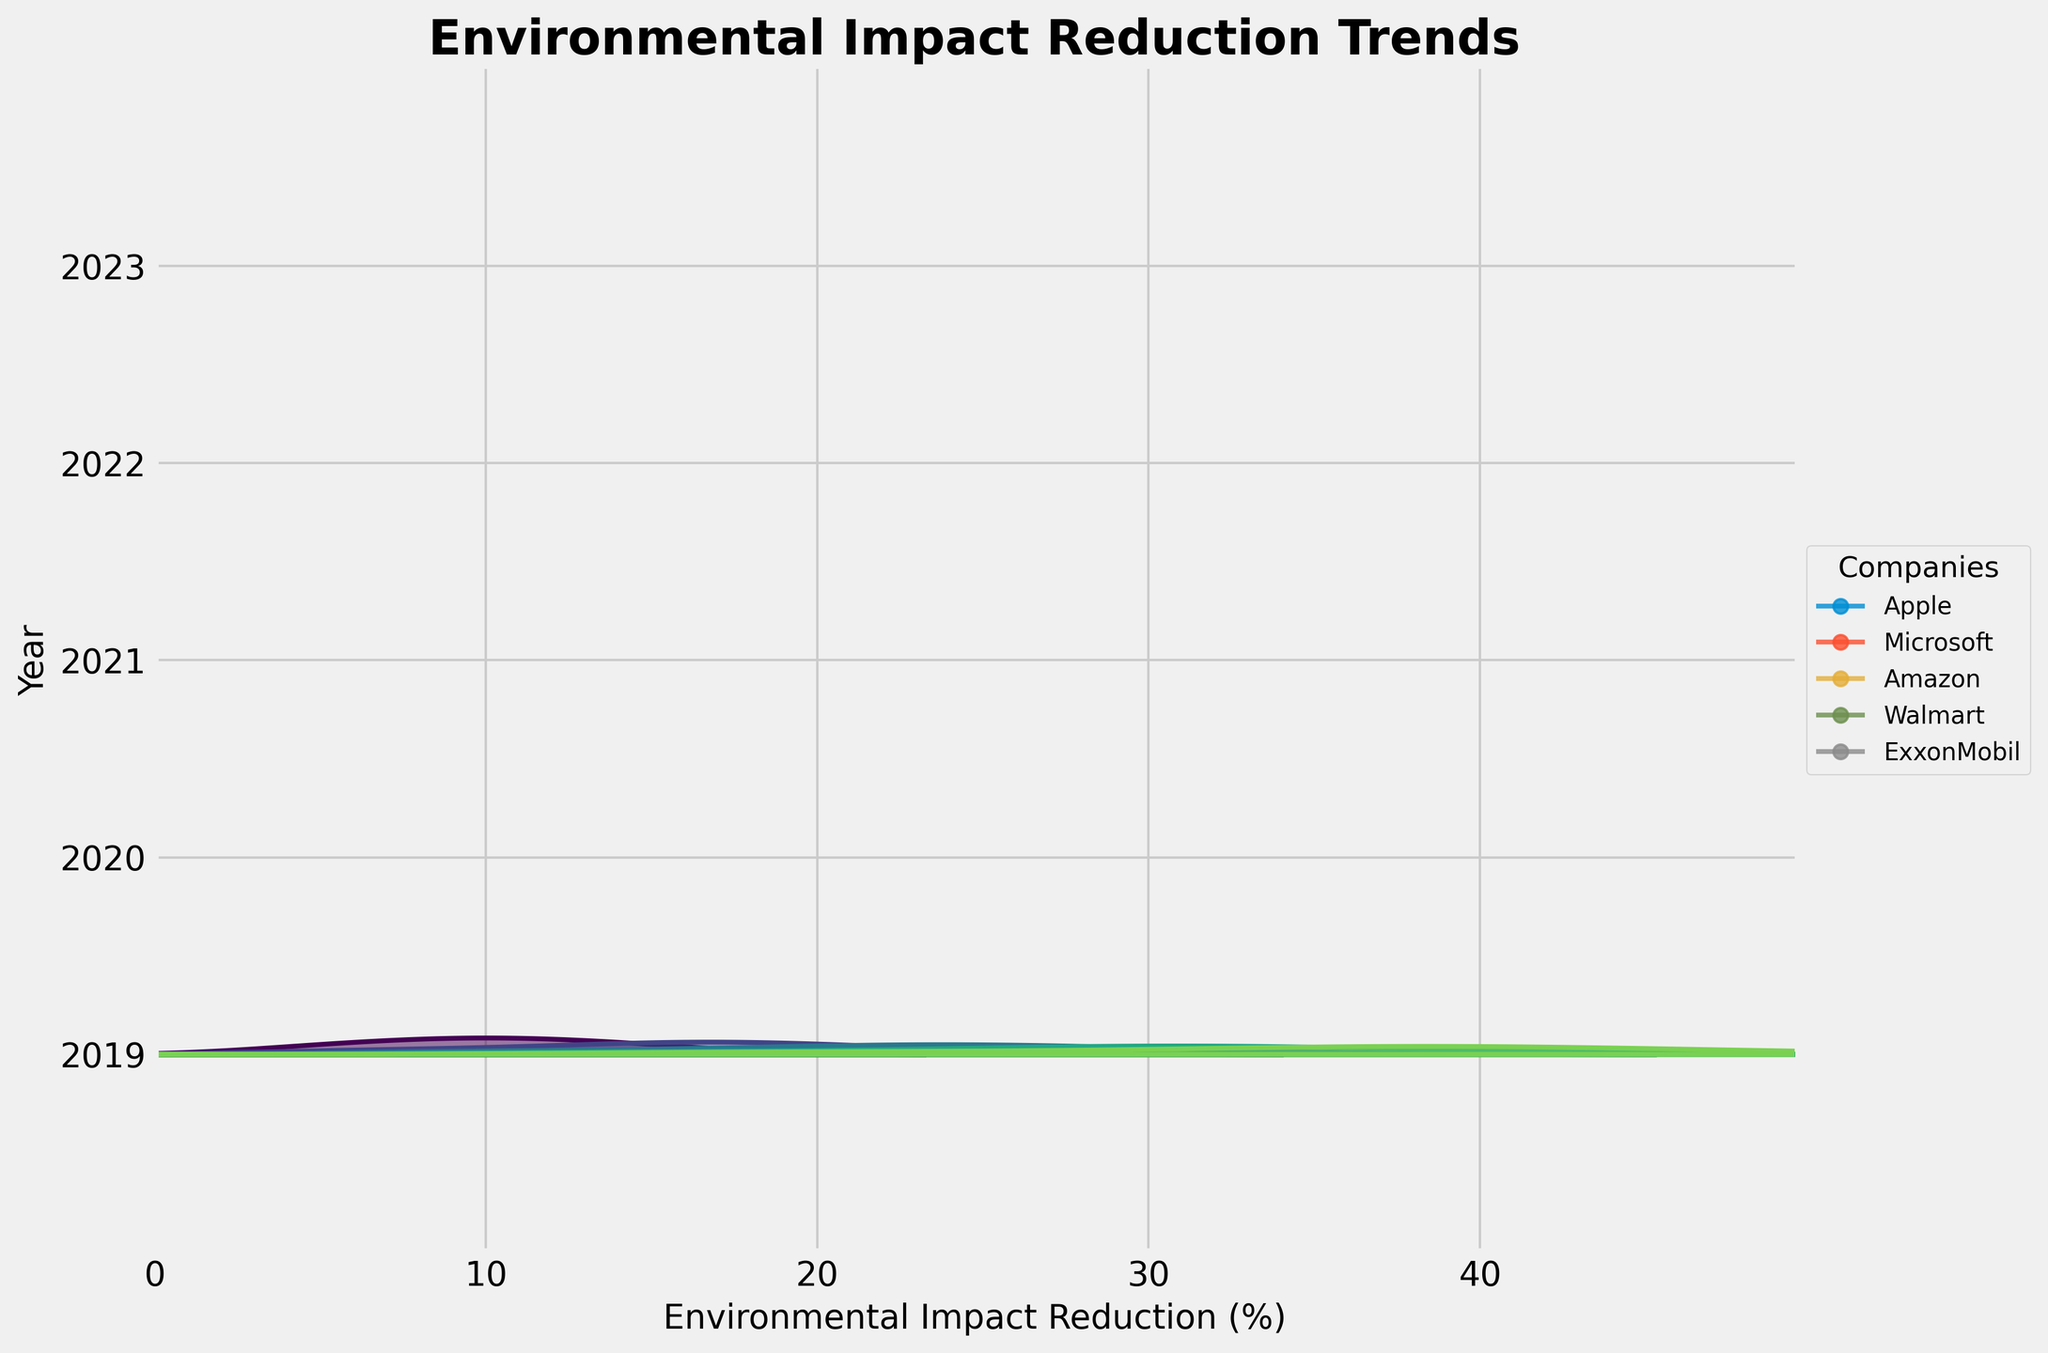How many years are displayed in the figure? The y-axis is labeled "Year," and it has five tick marks shown for 2019, 2020, 2021, 2022, and 2023.
Answer: 5 Which company has the highest environmental impact reduction in 2023? Looking at the plotted lines in the figure, Microsoft has the highest point on the environmental impact reduction axis in 2023.
Answer: Microsoft What is the color gradient representing in the plot? The shading in the plot transitions through different colors, which indicates the passage of years from earliest to latest, getting progressively darker.
Answer: Passage of years Calculate the average environmental impact reduction for Apple from 2019 to 2023. Gather the values for Apple from the y-axis labels: 12 (2019), 18 (2020), 25 (2021), 32 (2022), and 40 (2023). Sum these values: 12 + 18 + 25 + 32 + 40 = 127. Divide by 5 (the number of years): 127 / 5 = 25.4
Answer: 25.4 Which year shows the most significant overall improvement in environmental impact reduction across all companies? By observing the ridgeline densities, the peak shifts significantly in 2020 compared to 2019, showing a sharper increase for all companies.
Answer: 2020 Compare the environmental impact reduction percentage trends between Walmart and ExxonMobil from 2019 to 2023. Referring to their corresponding data points: Walmart starts at 10% in 2019 and ends at 36% in 2023, while ExxonMobil starts at 5% in 2019 and ends at 20% in 2023. Both improve, but Walmart's improvement trend is more substantial.
Answer: Walmart has a more significant improvement What is the minimum environmental impact reduction percentage achieved by any company in 2022? According to the data points plotted, ExxonMobil has the lowest reduction percentage in 2022 at 15%.
Answer: 15% Compare the environmental impact reduction achievements of Apple and Amazon in 2021. Apple achieved a 25% reduction, and Amazon had a 20% reduction in 2021, as seen from their respective points on the plot.
Answer: Apple > Amazon How does the variation in the environmental impact reduction of companies change over the years? The density plot bands get wider and more spread out as years progress, indicating more variation and incremental improvements in later years.
Answer: Greater variation over the years 